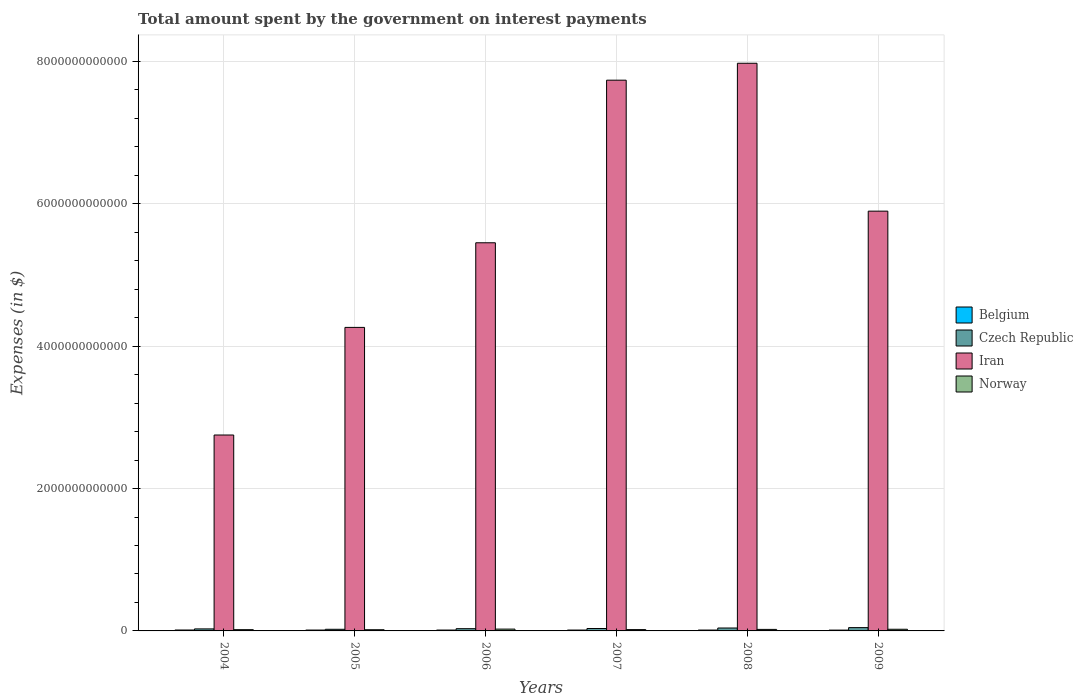How many different coloured bars are there?
Your response must be concise. 4. How many bars are there on the 3rd tick from the left?
Provide a succinct answer. 4. In how many cases, is the number of bars for a given year not equal to the number of legend labels?
Your response must be concise. 0. What is the amount spent on interest payments by the government in Belgium in 2008?
Give a very brief answer. 1.23e+1. Across all years, what is the maximum amount spent on interest payments by the government in Norway?
Keep it short and to the point. 2.56e+1. Across all years, what is the minimum amount spent on interest payments by the government in Belgium?
Your answer should be compact. 1.16e+1. What is the total amount spent on interest payments by the government in Iran in the graph?
Ensure brevity in your answer.  3.41e+13. What is the difference between the amount spent on interest payments by the government in Belgium in 2004 and that in 2008?
Your response must be concise. 5.26e+08. What is the difference between the amount spent on interest payments by the government in Iran in 2007 and the amount spent on interest payments by the government in Belgium in 2005?
Provide a short and direct response. 7.72e+12. What is the average amount spent on interest payments by the government in Belgium per year?
Offer a very short reply. 1.22e+1. In the year 2009, what is the difference between the amount spent on interest payments by the government in Norway and amount spent on interest payments by the government in Czech Republic?
Offer a very short reply. -2.29e+1. In how many years, is the amount spent on interest payments by the government in Iran greater than 5200000000000 $?
Your answer should be very brief. 4. What is the ratio of the amount spent on interest payments by the government in Czech Republic in 2004 to that in 2007?
Keep it short and to the point. 0.83. What is the difference between the highest and the second highest amount spent on interest payments by the government in Norway?
Your answer should be very brief. 2.15e+09. What is the difference between the highest and the lowest amount spent on interest payments by the government in Iran?
Your answer should be compact. 5.22e+12. In how many years, is the amount spent on interest payments by the government in Belgium greater than the average amount spent on interest payments by the government in Belgium taken over all years?
Make the answer very short. 3. Is the sum of the amount spent on interest payments by the government in Iran in 2007 and 2008 greater than the maximum amount spent on interest payments by the government in Czech Republic across all years?
Offer a very short reply. Yes. Is it the case that in every year, the sum of the amount spent on interest payments by the government in Iran and amount spent on interest payments by the government in Czech Republic is greater than the sum of amount spent on interest payments by the government in Belgium and amount spent on interest payments by the government in Norway?
Ensure brevity in your answer.  Yes. What does the 3rd bar from the left in 2008 represents?
Your answer should be compact. Iran. What does the 3rd bar from the right in 2008 represents?
Provide a succinct answer. Czech Republic. Is it the case that in every year, the sum of the amount spent on interest payments by the government in Czech Republic and amount spent on interest payments by the government in Belgium is greater than the amount spent on interest payments by the government in Norway?
Ensure brevity in your answer.  Yes. Are all the bars in the graph horizontal?
Give a very brief answer. No. What is the difference between two consecutive major ticks on the Y-axis?
Ensure brevity in your answer.  2.00e+12. Are the values on the major ticks of Y-axis written in scientific E-notation?
Ensure brevity in your answer.  No. Does the graph contain any zero values?
Your response must be concise. No. Does the graph contain grids?
Provide a short and direct response. Yes. Where does the legend appear in the graph?
Offer a terse response. Center right. How many legend labels are there?
Provide a succinct answer. 4. What is the title of the graph?
Ensure brevity in your answer.  Total amount spent by the government on interest payments. What is the label or title of the X-axis?
Offer a very short reply. Years. What is the label or title of the Y-axis?
Offer a terse response. Expenses (in $). What is the Expenses (in $) of Belgium in 2004?
Offer a terse response. 1.28e+1. What is the Expenses (in $) of Czech Republic in 2004?
Offer a terse response. 2.83e+1. What is the Expenses (in $) of Iran in 2004?
Your response must be concise. 2.75e+12. What is the Expenses (in $) in Norway in 2004?
Provide a short and direct response. 1.77e+1. What is the Expenses (in $) in Belgium in 2005?
Your answer should be compact. 1.22e+1. What is the Expenses (in $) of Czech Republic in 2005?
Ensure brevity in your answer.  2.30e+1. What is the Expenses (in $) of Iran in 2005?
Offer a terse response. 4.26e+12. What is the Expenses (in $) of Norway in 2005?
Your response must be concise. 1.67e+1. What is the Expenses (in $) in Belgium in 2006?
Your answer should be compact. 1.21e+1. What is the Expenses (in $) in Czech Republic in 2006?
Give a very brief answer. 3.14e+1. What is the Expenses (in $) of Iran in 2006?
Offer a terse response. 5.45e+12. What is the Expenses (in $) in Norway in 2006?
Provide a succinct answer. 2.56e+1. What is the Expenses (in $) in Belgium in 2007?
Offer a very short reply. 1.21e+1. What is the Expenses (in $) in Czech Republic in 2007?
Ensure brevity in your answer.  3.40e+1. What is the Expenses (in $) in Iran in 2007?
Give a very brief answer. 7.74e+12. What is the Expenses (in $) in Norway in 2007?
Provide a succinct answer. 1.86e+1. What is the Expenses (in $) in Belgium in 2008?
Make the answer very short. 1.23e+1. What is the Expenses (in $) of Czech Republic in 2008?
Keep it short and to the point. 4.09e+1. What is the Expenses (in $) in Iran in 2008?
Keep it short and to the point. 7.97e+12. What is the Expenses (in $) of Norway in 2008?
Your answer should be very brief. 2.13e+1. What is the Expenses (in $) of Belgium in 2009?
Ensure brevity in your answer.  1.16e+1. What is the Expenses (in $) in Czech Republic in 2009?
Keep it short and to the point. 4.64e+1. What is the Expenses (in $) of Iran in 2009?
Your answer should be very brief. 5.90e+12. What is the Expenses (in $) in Norway in 2009?
Provide a short and direct response. 2.34e+1. Across all years, what is the maximum Expenses (in $) in Belgium?
Offer a very short reply. 1.28e+1. Across all years, what is the maximum Expenses (in $) of Czech Republic?
Offer a terse response. 4.64e+1. Across all years, what is the maximum Expenses (in $) in Iran?
Ensure brevity in your answer.  7.97e+12. Across all years, what is the maximum Expenses (in $) in Norway?
Make the answer very short. 2.56e+1. Across all years, what is the minimum Expenses (in $) of Belgium?
Offer a very short reply. 1.16e+1. Across all years, what is the minimum Expenses (in $) of Czech Republic?
Provide a short and direct response. 2.30e+1. Across all years, what is the minimum Expenses (in $) in Iran?
Provide a succinct answer. 2.75e+12. Across all years, what is the minimum Expenses (in $) in Norway?
Your answer should be compact. 1.67e+1. What is the total Expenses (in $) of Belgium in the graph?
Your response must be concise. 7.30e+1. What is the total Expenses (in $) in Czech Republic in the graph?
Make the answer very short. 2.04e+11. What is the total Expenses (in $) of Iran in the graph?
Keep it short and to the point. 3.41e+13. What is the total Expenses (in $) of Norway in the graph?
Provide a succinct answer. 1.23e+11. What is the difference between the Expenses (in $) in Belgium in 2004 and that in 2005?
Provide a short and direct response. 6.13e+08. What is the difference between the Expenses (in $) of Czech Republic in 2004 and that in 2005?
Keep it short and to the point. 5.31e+09. What is the difference between the Expenses (in $) in Iran in 2004 and that in 2005?
Your response must be concise. -1.51e+12. What is the difference between the Expenses (in $) in Norway in 2004 and that in 2005?
Make the answer very short. 9.82e+08. What is the difference between the Expenses (in $) of Belgium in 2004 and that in 2006?
Ensure brevity in your answer.  7.07e+08. What is the difference between the Expenses (in $) of Czech Republic in 2004 and that in 2006?
Your response must be concise. -3.06e+09. What is the difference between the Expenses (in $) in Iran in 2004 and that in 2006?
Your answer should be compact. -2.70e+12. What is the difference between the Expenses (in $) in Norway in 2004 and that in 2006?
Ensure brevity in your answer.  -7.91e+09. What is the difference between the Expenses (in $) of Belgium in 2004 and that in 2007?
Ensure brevity in your answer.  6.55e+08. What is the difference between the Expenses (in $) of Czech Republic in 2004 and that in 2007?
Offer a very short reply. -5.62e+09. What is the difference between the Expenses (in $) in Iran in 2004 and that in 2007?
Provide a short and direct response. -4.98e+12. What is the difference between the Expenses (in $) in Norway in 2004 and that in 2007?
Your answer should be compact. -8.98e+08. What is the difference between the Expenses (in $) in Belgium in 2004 and that in 2008?
Your answer should be compact. 5.26e+08. What is the difference between the Expenses (in $) of Czech Republic in 2004 and that in 2008?
Make the answer very short. -1.26e+1. What is the difference between the Expenses (in $) of Iran in 2004 and that in 2008?
Offer a terse response. -5.22e+12. What is the difference between the Expenses (in $) of Norway in 2004 and that in 2008?
Your answer should be compact. -3.65e+09. What is the difference between the Expenses (in $) of Belgium in 2004 and that in 2009?
Give a very brief answer. 1.23e+09. What is the difference between the Expenses (in $) of Czech Republic in 2004 and that in 2009?
Offer a terse response. -1.80e+1. What is the difference between the Expenses (in $) in Iran in 2004 and that in 2009?
Keep it short and to the point. -3.14e+12. What is the difference between the Expenses (in $) of Norway in 2004 and that in 2009?
Provide a succinct answer. -5.76e+09. What is the difference between the Expenses (in $) in Belgium in 2005 and that in 2006?
Provide a succinct answer. 9.46e+07. What is the difference between the Expenses (in $) of Czech Republic in 2005 and that in 2006?
Provide a short and direct response. -8.37e+09. What is the difference between the Expenses (in $) in Iran in 2005 and that in 2006?
Give a very brief answer. -1.19e+12. What is the difference between the Expenses (in $) in Norway in 2005 and that in 2006?
Give a very brief answer. -8.89e+09. What is the difference between the Expenses (in $) in Belgium in 2005 and that in 2007?
Offer a terse response. 4.20e+07. What is the difference between the Expenses (in $) of Czech Republic in 2005 and that in 2007?
Your answer should be very brief. -1.09e+1. What is the difference between the Expenses (in $) of Iran in 2005 and that in 2007?
Provide a short and direct response. -3.47e+12. What is the difference between the Expenses (in $) of Norway in 2005 and that in 2007?
Make the answer very short. -1.88e+09. What is the difference between the Expenses (in $) in Belgium in 2005 and that in 2008?
Make the answer very short. -8.66e+07. What is the difference between the Expenses (in $) of Czech Republic in 2005 and that in 2008?
Your answer should be very brief. -1.79e+1. What is the difference between the Expenses (in $) of Iran in 2005 and that in 2008?
Give a very brief answer. -3.71e+12. What is the difference between the Expenses (in $) in Norway in 2005 and that in 2008?
Your answer should be compact. -4.63e+09. What is the difference between the Expenses (in $) of Belgium in 2005 and that in 2009?
Offer a terse response. 6.20e+08. What is the difference between the Expenses (in $) in Czech Republic in 2005 and that in 2009?
Your response must be concise. -2.33e+1. What is the difference between the Expenses (in $) in Iran in 2005 and that in 2009?
Your response must be concise. -1.63e+12. What is the difference between the Expenses (in $) of Norway in 2005 and that in 2009?
Provide a short and direct response. -6.74e+09. What is the difference between the Expenses (in $) of Belgium in 2006 and that in 2007?
Offer a terse response. -5.26e+07. What is the difference between the Expenses (in $) of Czech Republic in 2006 and that in 2007?
Keep it short and to the point. -2.56e+09. What is the difference between the Expenses (in $) in Iran in 2006 and that in 2007?
Ensure brevity in your answer.  -2.28e+12. What is the difference between the Expenses (in $) of Norway in 2006 and that in 2007?
Give a very brief answer. 7.01e+09. What is the difference between the Expenses (in $) in Belgium in 2006 and that in 2008?
Provide a succinct answer. -1.81e+08. What is the difference between the Expenses (in $) of Czech Republic in 2006 and that in 2008?
Offer a terse response. -9.55e+09. What is the difference between the Expenses (in $) in Iran in 2006 and that in 2008?
Provide a succinct answer. -2.52e+12. What is the difference between the Expenses (in $) in Norway in 2006 and that in 2008?
Ensure brevity in your answer.  4.26e+09. What is the difference between the Expenses (in $) in Belgium in 2006 and that in 2009?
Offer a terse response. 5.25e+08. What is the difference between the Expenses (in $) of Czech Republic in 2006 and that in 2009?
Provide a short and direct response. -1.50e+1. What is the difference between the Expenses (in $) of Iran in 2006 and that in 2009?
Your response must be concise. -4.44e+11. What is the difference between the Expenses (in $) in Norway in 2006 and that in 2009?
Your answer should be compact. 2.15e+09. What is the difference between the Expenses (in $) of Belgium in 2007 and that in 2008?
Provide a short and direct response. -1.29e+08. What is the difference between the Expenses (in $) of Czech Republic in 2007 and that in 2008?
Ensure brevity in your answer.  -6.98e+09. What is the difference between the Expenses (in $) in Iran in 2007 and that in 2008?
Keep it short and to the point. -2.38e+11. What is the difference between the Expenses (in $) in Norway in 2007 and that in 2008?
Your answer should be very brief. -2.75e+09. What is the difference between the Expenses (in $) of Belgium in 2007 and that in 2009?
Provide a short and direct response. 5.78e+08. What is the difference between the Expenses (in $) in Czech Republic in 2007 and that in 2009?
Give a very brief answer. -1.24e+1. What is the difference between the Expenses (in $) of Iran in 2007 and that in 2009?
Provide a short and direct response. 1.84e+12. What is the difference between the Expenses (in $) in Norway in 2007 and that in 2009?
Give a very brief answer. -4.86e+09. What is the difference between the Expenses (in $) in Belgium in 2008 and that in 2009?
Provide a short and direct response. 7.06e+08. What is the difference between the Expenses (in $) in Czech Republic in 2008 and that in 2009?
Offer a very short reply. -5.42e+09. What is the difference between the Expenses (in $) of Iran in 2008 and that in 2009?
Provide a short and direct response. 2.08e+12. What is the difference between the Expenses (in $) of Norway in 2008 and that in 2009?
Provide a short and direct response. -2.11e+09. What is the difference between the Expenses (in $) in Belgium in 2004 and the Expenses (in $) in Czech Republic in 2005?
Give a very brief answer. -1.02e+1. What is the difference between the Expenses (in $) of Belgium in 2004 and the Expenses (in $) of Iran in 2005?
Make the answer very short. -4.25e+12. What is the difference between the Expenses (in $) of Belgium in 2004 and the Expenses (in $) of Norway in 2005?
Provide a short and direct response. -3.91e+09. What is the difference between the Expenses (in $) in Czech Republic in 2004 and the Expenses (in $) in Iran in 2005?
Offer a very short reply. -4.24e+12. What is the difference between the Expenses (in $) of Czech Republic in 2004 and the Expenses (in $) of Norway in 2005?
Give a very brief answer. 1.16e+1. What is the difference between the Expenses (in $) in Iran in 2004 and the Expenses (in $) in Norway in 2005?
Keep it short and to the point. 2.74e+12. What is the difference between the Expenses (in $) of Belgium in 2004 and the Expenses (in $) of Czech Republic in 2006?
Offer a very short reply. -1.86e+1. What is the difference between the Expenses (in $) in Belgium in 2004 and the Expenses (in $) in Iran in 2006?
Make the answer very short. -5.44e+12. What is the difference between the Expenses (in $) of Belgium in 2004 and the Expenses (in $) of Norway in 2006?
Your answer should be very brief. -1.28e+1. What is the difference between the Expenses (in $) of Czech Republic in 2004 and the Expenses (in $) of Iran in 2006?
Make the answer very short. -5.42e+12. What is the difference between the Expenses (in $) in Czech Republic in 2004 and the Expenses (in $) in Norway in 2006?
Ensure brevity in your answer.  2.75e+09. What is the difference between the Expenses (in $) in Iran in 2004 and the Expenses (in $) in Norway in 2006?
Offer a very short reply. 2.73e+12. What is the difference between the Expenses (in $) in Belgium in 2004 and the Expenses (in $) in Czech Republic in 2007?
Provide a short and direct response. -2.12e+1. What is the difference between the Expenses (in $) in Belgium in 2004 and the Expenses (in $) in Iran in 2007?
Keep it short and to the point. -7.72e+12. What is the difference between the Expenses (in $) of Belgium in 2004 and the Expenses (in $) of Norway in 2007?
Your answer should be compact. -5.79e+09. What is the difference between the Expenses (in $) of Czech Republic in 2004 and the Expenses (in $) of Iran in 2007?
Your answer should be compact. -7.71e+12. What is the difference between the Expenses (in $) of Czech Republic in 2004 and the Expenses (in $) of Norway in 2007?
Ensure brevity in your answer.  9.76e+09. What is the difference between the Expenses (in $) in Iran in 2004 and the Expenses (in $) in Norway in 2007?
Your response must be concise. 2.73e+12. What is the difference between the Expenses (in $) of Belgium in 2004 and the Expenses (in $) of Czech Republic in 2008?
Keep it short and to the point. -2.82e+1. What is the difference between the Expenses (in $) of Belgium in 2004 and the Expenses (in $) of Iran in 2008?
Ensure brevity in your answer.  -7.96e+12. What is the difference between the Expenses (in $) in Belgium in 2004 and the Expenses (in $) in Norway in 2008?
Offer a very short reply. -8.54e+09. What is the difference between the Expenses (in $) of Czech Republic in 2004 and the Expenses (in $) of Iran in 2008?
Make the answer very short. -7.95e+12. What is the difference between the Expenses (in $) in Czech Republic in 2004 and the Expenses (in $) in Norway in 2008?
Offer a very short reply. 7.01e+09. What is the difference between the Expenses (in $) in Iran in 2004 and the Expenses (in $) in Norway in 2008?
Ensure brevity in your answer.  2.73e+12. What is the difference between the Expenses (in $) in Belgium in 2004 and the Expenses (in $) in Czech Republic in 2009?
Keep it short and to the point. -3.36e+1. What is the difference between the Expenses (in $) in Belgium in 2004 and the Expenses (in $) in Iran in 2009?
Ensure brevity in your answer.  -5.88e+12. What is the difference between the Expenses (in $) of Belgium in 2004 and the Expenses (in $) of Norway in 2009?
Ensure brevity in your answer.  -1.07e+1. What is the difference between the Expenses (in $) in Czech Republic in 2004 and the Expenses (in $) in Iran in 2009?
Make the answer very short. -5.87e+12. What is the difference between the Expenses (in $) in Czech Republic in 2004 and the Expenses (in $) in Norway in 2009?
Ensure brevity in your answer.  4.90e+09. What is the difference between the Expenses (in $) of Iran in 2004 and the Expenses (in $) of Norway in 2009?
Keep it short and to the point. 2.73e+12. What is the difference between the Expenses (in $) of Belgium in 2005 and the Expenses (in $) of Czech Republic in 2006?
Offer a very short reply. -1.92e+1. What is the difference between the Expenses (in $) in Belgium in 2005 and the Expenses (in $) in Iran in 2006?
Offer a very short reply. -5.44e+12. What is the difference between the Expenses (in $) of Belgium in 2005 and the Expenses (in $) of Norway in 2006?
Provide a short and direct response. -1.34e+1. What is the difference between the Expenses (in $) of Czech Republic in 2005 and the Expenses (in $) of Iran in 2006?
Ensure brevity in your answer.  -5.43e+12. What is the difference between the Expenses (in $) in Czech Republic in 2005 and the Expenses (in $) in Norway in 2006?
Offer a very short reply. -2.56e+09. What is the difference between the Expenses (in $) of Iran in 2005 and the Expenses (in $) of Norway in 2006?
Offer a very short reply. 4.24e+12. What is the difference between the Expenses (in $) in Belgium in 2005 and the Expenses (in $) in Czech Republic in 2007?
Your answer should be very brief. -2.18e+1. What is the difference between the Expenses (in $) in Belgium in 2005 and the Expenses (in $) in Iran in 2007?
Provide a succinct answer. -7.72e+12. What is the difference between the Expenses (in $) in Belgium in 2005 and the Expenses (in $) in Norway in 2007?
Provide a short and direct response. -6.41e+09. What is the difference between the Expenses (in $) of Czech Republic in 2005 and the Expenses (in $) of Iran in 2007?
Provide a succinct answer. -7.71e+12. What is the difference between the Expenses (in $) in Czech Republic in 2005 and the Expenses (in $) in Norway in 2007?
Keep it short and to the point. 4.45e+09. What is the difference between the Expenses (in $) in Iran in 2005 and the Expenses (in $) in Norway in 2007?
Offer a terse response. 4.25e+12. What is the difference between the Expenses (in $) in Belgium in 2005 and the Expenses (in $) in Czech Republic in 2008?
Make the answer very short. -2.88e+1. What is the difference between the Expenses (in $) in Belgium in 2005 and the Expenses (in $) in Iran in 2008?
Provide a short and direct response. -7.96e+12. What is the difference between the Expenses (in $) of Belgium in 2005 and the Expenses (in $) of Norway in 2008?
Offer a very short reply. -9.16e+09. What is the difference between the Expenses (in $) in Czech Republic in 2005 and the Expenses (in $) in Iran in 2008?
Provide a succinct answer. -7.95e+12. What is the difference between the Expenses (in $) of Czech Republic in 2005 and the Expenses (in $) of Norway in 2008?
Offer a terse response. 1.70e+09. What is the difference between the Expenses (in $) in Iran in 2005 and the Expenses (in $) in Norway in 2008?
Your response must be concise. 4.24e+12. What is the difference between the Expenses (in $) in Belgium in 2005 and the Expenses (in $) in Czech Republic in 2009?
Offer a very short reply. -3.42e+1. What is the difference between the Expenses (in $) in Belgium in 2005 and the Expenses (in $) in Iran in 2009?
Keep it short and to the point. -5.88e+12. What is the difference between the Expenses (in $) in Belgium in 2005 and the Expenses (in $) in Norway in 2009?
Give a very brief answer. -1.13e+1. What is the difference between the Expenses (in $) of Czech Republic in 2005 and the Expenses (in $) of Iran in 2009?
Give a very brief answer. -5.87e+12. What is the difference between the Expenses (in $) in Czech Republic in 2005 and the Expenses (in $) in Norway in 2009?
Offer a terse response. -4.14e+08. What is the difference between the Expenses (in $) in Iran in 2005 and the Expenses (in $) in Norway in 2009?
Keep it short and to the point. 4.24e+12. What is the difference between the Expenses (in $) in Belgium in 2006 and the Expenses (in $) in Czech Republic in 2007?
Your response must be concise. -2.19e+1. What is the difference between the Expenses (in $) in Belgium in 2006 and the Expenses (in $) in Iran in 2007?
Offer a terse response. -7.72e+12. What is the difference between the Expenses (in $) of Belgium in 2006 and the Expenses (in $) of Norway in 2007?
Your answer should be compact. -6.50e+09. What is the difference between the Expenses (in $) in Czech Republic in 2006 and the Expenses (in $) in Iran in 2007?
Ensure brevity in your answer.  -7.71e+12. What is the difference between the Expenses (in $) of Czech Republic in 2006 and the Expenses (in $) of Norway in 2007?
Ensure brevity in your answer.  1.28e+1. What is the difference between the Expenses (in $) in Iran in 2006 and the Expenses (in $) in Norway in 2007?
Keep it short and to the point. 5.43e+12. What is the difference between the Expenses (in $) in Belgium in 2006 and the Expenses (in $) in Czech Republic in 2008?
Your answer should be very brief. -2.89e+1. What is the difference between the Expenses (in $) of Belgium in 2006 and the Expenses (in $) of Iran in 2008?
Your answer should be very brief. -7.96e+12. What is the difference between the Expenses (in $) in Belgium in 2006 and the Expenses (in $) in Norway in 2008?
Provide a short and direct response. -9.25e+09. What is the difference between the Expenses (in $) of Czech Republic in 2006 and the Expenses (in $) of Iran in 2008?
Ensure brevity in your answer.  -7.94e+12. What is the difference between the Expenses (in $) in Czech Republic in 2006 and the Expenses (in $) in Norway in 2008?
Ensure brevity in your answer.  1.01e+1. What is the difference between the Expenses (in $) in Iran in 2006 and the Expenses (in $) in Norway in 2008?
Ensure brevity in your answer.  5.43e+12. What is the difference between the Expenses (in $) of Belgium in 2006 and the Expenses (in $) of Czech Republic in 2009?
Offer a very short reply. -3.43e+1. What is the difference between the Expenses (in $) of Belgium in 2006 and the Expenses (in $) of Iran in 2009?
Keep it short and to the point. -5.88e+12. What is the difference between the Expenses (in $) of Belgium in 2006 and the Expenses (in $) of Norway in 2009?
Give a very brief answer. -1.14e+1. What is the difference between the Expenses (in $) in Czech Republic in 2006 and the Expenses (in $) in Iran in 2009?
Your response must be concise. -5.87e+12. What is the difference between the Expenses (in $) of Czech Republic in 2006 and the Expenses (in $) of Norway in 2009?
Offer a very short reply. 7.96e+09. What is the difference between the Expenses (in $) in Iran in 2006 and the Expenses (in $) in Norway in 2009?
Offer a terse response. 5.43e+12. What is the difference between the Expenses (in $) in Belgium in 2007 and the Expenses (in $) in Czech Republic in 2008?
Your answer should be very brief. -2.88e+1. What is the difference between the Expenses (in $) in Belgium in 2007 and the Expenses (in $) in Iran in 2008?
Keep it short and to the point. -7.96e+12. What is the difference between the Expenses (in $) of Belgium in 2007 and the Expenses (in $) of Norway in 2008?
Provide a succinct answer. -9.20e+09. What is the difference between the Expenses (in $) of Czech Republic in 2007 and the Expenses (in $) of Iran in 2008?
Keep it short and to the point. -7.94e+12. What is the difference between the Expenses (in $) in Czech Republic in 2007 and the Expenses (in $) in Norway in 2008?
Offer a very short reply. 1.26e+1. What is the difference between the Expenses (in $) in Iran in 2007 and the Expenses (in $) in Norway in 2008?
Give a very brief answer. 7.72e+12. What is the difference between the Expenses (in $) in Belgium in 2007 and the Expenses (in $) in Czech Republic in 2009?
Your answer should be compact. -3.42e+1. What is the difference between the Expenses (in $) of Belgium in 2007 and the Expenses (in $) of Iran in 2009?
Offer a very short reply. -5.88e+12. What is the difference between the Expenses (in $) in Belgium in 2007 and the Expenses (in $) in Norway in 2009?
Make the answer very short. -1.13e+1. What is the difference between the Expenses (in $) in Czech Republic in 2007 and the Expenses (in $) in Iran in 2009?
Offer a terse response. -5.86e+12. What is the difference between the Expenses (in $) in Czech Republic in 2007 and the Expenses (in $) in Norway in 2009?
Keep it short and to the point. 1.05e+1. What is the difference between the Expenses (in $) of Iran in 2007 and the Expenses (in $) of Norway in 2009?
Keep it short and to the point. 7.71e+12. What is the difference between the Expenses (in $) of Belgium in 2008 and the Expenses (in $) of Czech Republic in 2009?
Provide a succinct answer. -3.41e+1. What is the difference between the Expenses (in $) in Belgium in 2008 and the Expenses (in $) in Iran in 2009?
Make the answer very short. -5.88e+12. What is the difference between the Expenses (in $) of Belgium in 2008 and the Expenses (in $) of Norway in 2009?
Offer a terse response. -1.12e+1. What is the difference between the Expenses (in $) in Czech Republic in 2008 and the Expenses (in $) in Iran in 2009?
Provide a short and direct response. -5.86e+12. What is the difference between the Expenses (in $) of Czech Republic in 2008 and the Expenses (in $) of Norway in 2009?
Keep it short and to the point. 1.75e+1. What is the difference between the Expenses (in $) in Iran in 2008 and the Expenses (in $) in Norway in 2009?
Your answer should be very brief. 7.95e+12. What is the average Expenses (in $) in Belgium per year?
Provide a succinct answer. 1.22e+1. What is the average Expenses (in $) in Czech Republic per year?
Offer a very short reply. 3.40e+1. What is the average Expenses (in $) in Iran per year?
Ensure brevity in your answer.  5.68e+12. What is the average Expenses (in $) of Norway per year?
Your response must be concise. 2.06e+1. In the year 2004, what is the difference between the Expenses (in $) of Belgium and Expenses (in $) of Czech Republic?
Your answer should be compact. -1.56e+1. In the year 2004, what is the difference between the Expenses (in $) in Belgium and Expenses (in $) in Iran?
Provide a short and direct response. -2.74e+12. In the year 2004, what is the difference between the Expenses (in $) in Belgium and Expenses (in $) in Norway?
Your response must be concise. -4.90e+09. In the year 2004, what is the difference between the Expenses (in $) in Czech Republic and Expenses (in $) in Iran?
Provide a short and direct response. -2.72e+12. In the year 2004, what is the difference between the Expenses (in $) of Czech Republic and Expenses (in $) of Norway?
Give a very brief answer. 1.07e+1. In the year 2004, what is the difference between the Expenses (in $) of Iran and Expenses (in $) of Norway?
Provide a succinct answer. 2.73e+12. In the year 2005, what is the difference between the Expenses (in $) of Belgium and Expenses (in $) of Czech Republic?
Offer a very short reply. -1.09e+1. In the year 2005, what is the difference between the Expenses (in $) of Belgium and Expenses (in $) of Iran?
Ensure brevity in your answer.  -4.25e+12. In the year 2005, what is the difference between the Expenses (in $) of Belgium and Expenses (in $) of Norway?
Give a very brief answer. -4.53e+09. In the year 2005, what is the difference between the Expenses (in $) of Czech Republic and Expenses (in $) of Iran?
Provide a short and direct response. -4.24e+12. In the year 2005, what is the difference between the Expenses (in $) in Czech Republic and Expenses (in $) in Norway?
Your answer should be very brief. 6.33e+09. In the year 2005, what is the difference between the Expenses (in $) in Iran and Expenses (in $) in Norway?
Make the answer very short. 4.25e+12. In the year 2006, what is the difference between the Expenses (in $) in Belgium and Expenses (in $) in Czech Republic?
Offer a very short reply. -1.93e+1. In the year 2006, what is the difference between the Expenses (in $) of Belgium and Expenses (in $) of Iran?
Provide a succinct answer. -5.44e+12. In the year 2006, what is the difference between the Expenses (in $) of Belgium and Expenses (in $) of Norway?
Provide a succinct answer. -1.35e+1. In the year 2006, what is the difference between the Expenses (in $) of Czech Republic and Expenses (in $) of Iran?
Offer a very short reply. -5.42e+12. In the year 2006, what is the difference between the Expenses (in $) of Czech Republic and Expenses (in $) of Norway?
Your response must be concise. 5.81e+09. In the year 2006, what is the difference between the Expenses (in $) in Iran and Expenses (in $) in Norway?
Give a very brief answer. 5.43e+12. In the year 2007, what is the difference between the Expenses (in $) in Belgium and Expenses (in $) in Czech Republic?
Give a very brief answer. -2.18e+1. In the year 2007, what is the difference between the Expenses (in $) of Belgium and Expenses (in $) of Iran?
Provide a short and direct response. -7.72e+12. In the year 2007, what is the difference between the Expenses (in $) of Belgium and Expenses (in $) of Norway?
Provide a short and direct response. -6.45e+09. In the year 2007, what is the difference between the Expenses (in $) in Czech Republic and Expenses (in $) in Iran?
Ensure brevity in your answer.  -7.70e+12. In the year 2007, what is the difference between the Expenses (in $) in Czech Republic and Expenses (in $) in Norway?
Give a very brief answer. 1.54e+1. In the year 2007, what is the difference between the Expenses (in $) in Iran and Expenses (in $) in Norway?
Your response must be concise. 7.72e+12. In the year 2008, what is the difference between the Expenses (in $) in Belgium and Expenses (in $) in Czech Republic?
Give a very brief answer. -2.87e+1. In the year 2008, what is the difference between the Expenses (in $) of Belgium and Expenses (in $) of Iran?
Offer a very short reply. -7.96e+12. In the year 2008, what is the difference between the Expenses (in $) in Belgium and Expenses (in $) in Norway?
Provide a succinct answer. -9.07e+09. In the year 2008, what is the difference between the Expenses (in $) in Czech Republic and Expenses (in $) in Iran?
Keep it short and to the point. -7.93e+12. In the year 2008, what is the difference between the Expenses (in $) of Czech Republic and Expenses (in $) of Norway?
Your answer should be very brief. 1.96e+1. In the year 2008, what is the difference between the Expenses (in $) of Iran and Expenses (in $) of Norway?
Make the answer very short. 7.95e+12. In the year 2009, what is the difference between the Expenses (in $) in Belgium and Expenses (in $) in Czech Republic?
Ensure brevity in your answer.  -3.48e+1. In the year 2009, what is the difference between the Expenses (in $) of Belgium and Expenses (in $) of Iran?
Ensure brevity in your answer.  -5.89e+12. In the year 2009, what is the difference between the Expenses (in $) in Belgium and Expenses (in $) in Norway?
Provide a succinct answer. -1.19e+1. In the year 2009, what is the difference between the Expenses (in $) of Czech Republic and Expenses (in $) of Iran?
Your response must be concise. -5.85e+12. In the year 2009, what is the difference between the Expenses (in $) in Czech Republic and Expenses (in $) in Norway?
Offer a very short reply. 2.29e+1. In the year 2009, what is the difference between the Expenses (in $) in Iran and Expenses (in $) in Norway?
Your answer should be compact. 5.87e+12. What is the ratio of the Expenses (in $) in Belgium in 2004 to that in 2005?
Provide a succinct answer. 1.05. What is the ratio of the Expenses (in $) of Czech Republic in 2004 to that in 2005?
Offer a very short reply. 1.23. What is the ratio of the Expenses (in $) in Iran in 2004 to that in 2005?
Your answer should be very brief. 0.65. What is the ratio of the Expenses (in $) of Norway in 2004 to that in 2005?
Offer a very short reply. 1.06. What is the ratio of the Expenses (in $) in Belgium in 2004 to that in 2006?
Your answer should be compact. 1.06. What is the ratio of the Expenses (in $) of Czech Republic in 2004 to that in 2006?
Keep it short and to the point. 0.9. What is the ratio of the Expenses (in $) in Iran in 2004 to that in 2006?
Give a very brief answer. 0.5. What is the ratio of the Expenses (in $) in Norway in 2004 to that in 2006?
Provide a succinct answer. 0.69. What is the ratio of the Expenses (in $) of Belgium in 2004 to that in 2007?
Provide a succinct answer. 1.05. What is the ratio of the Expenses (in $) of Czech Republic in 2004 to that in 2007?
Your response must be concise. 0.83. What is the ratio of the Expenses (in $) in Iran in 2004 to that in 2007?
Provide a short and direct response. 0.36. What is the ratio of the Expenses (in $) in Norway in 2004 to that in 2007?
Your answer should be very brief. 0.95. What is the ratio of the Expenses (in $) in Belgium in 2004 to that in 2008?
Make the answer very short. 1.04. What is the ratio of the Expenses (in $) in Czech Republic in 2004 to that in 2008?
Offer a very short reply. 0.69. What is the ratio of the Expenses (in $) of Iran in 2004 to that in 2008?
Keep it short and to the point. 0.35. What is the ratio of the Expenses (in $) in Norway in 2004 to that in 2008?
Keep it short and to the point. 0.83. What is the ratio of the Expenses (in $) of Belgium in 2004 to that in 2009?
Offer a very short reply. 1.11. What is the ratio of the Expenses (in $) in Czech Republic in 2004 to that in 2009?
Provide a short and direct response. 0.61. What is the ratio of the Expenses (in $) of Iran in 2004 to that in 2009?
Your answer should be compact. 0.47. What is the ratio of the Expenses (in $) in Norway in 2004 to that in 2009?
Ensure brevity in your answer.  0.75. What is the ratio of the Expenses (in $) of Belgium in 2005 to that in 2006?
Make the answer very short. 1.01. What is the ratio of the Expenses (in $) of Czech Republic in 2005 to that in 2006?
Offer a terse response. 0.73. What is the ratio of the Expenses (in $) of Iran in 2005 to that in 2006?
Offer a terse response. 0.78. What is the ratio of the Expenses (in $) of Norway in 2005 to that in 2006?
Provide a succinct answer. 0.65. What is the ratio of the Expenses (in $) of Belgium in 2005 to that in 2007?
Keep it short and to the point. 1. What is the ratio of the Expenses (in $) in Czech Republic in 2005 to that in 2007?
Your answer should be compact. 0.68. What is the ratio of the Expenses (in $) of Iran in 2005 to that in 2007?
Give a very brief answer. 0.55. What is the ratio of the Expenses (in $) of Norway in 2005 to that in 2007?
Your answer should be compact. 0.9. What is the ratio of the Expenses (in $) in Belgium in 2005 to that in 2008?
Ensure brevity in your answer.  0.99. What is the ratio of the Expenses (in $) in Czech Republic in 2005 to that in 2008?
Offer a very short reply. 0.56. What is the ratio of the Expenses (in $) of Iran in 2005 to that in 2008?
Give a very brief answer. 0.53. What is the ratio of the Expenses (in $) in Norway in 2005 to that in 2008?
Your answer should be very brief. 0.78. What is the ratio of the Expenses (in $) of Belgium in 2005 to that in 2009?
Your answer should be very brief. 1.05. What is the ratio of the Expenses (in $) in Czech Republic in 2005 to that in 2009?
Provide a short and direct response. 0.5. What is the ratio of the Expenses (in $) in Iran in 2005 to that in 2009?
Offer a very short reply. 0.72. What is the ratio of the Expenses (in $) of Norway in 2005 to that in 2009?
Offer a terse response. 0.71. What is the ratio of the Expenses (in $) of Czech Republic in 2006 to that in 2007?
Your answer should be compact. 0.92. What is the ratio of the Expenses (in $) in Iran in 2006 to that in 2007?
Provide a short and direct response. 0.7. What is the ratio of the Expenses (in $) of Norway in 2006 to that in 2007?
Offer a very short reply. 1.38. What is the ratio of the Expenses (in $) of Belgium in 2006 to that in 2008?
Ensure brevity in your answer.  0.99. What is the ratio of the Expenses (in $) of Czech Republic in 2006 to that in 2008?
Your answer should be very brief. 0.77. What is the ratio of the Expenses (in $) in Iran in 2006 to that in 2008?
Offer a very short reply. 0.68. What is the ratio of the Expenses (in $) of Norway in 2006 to that in 2008?
Keep it short and to the point. 1.2. What is the ratio of the Expenses (in $) in Belgium in 2006 to that in 2009?
Your answer should be very brief. 1.05. What is the ratio of the Expenses (in $) of Czech Republic in 2006 to that in 2009?
Give a very brief answer. 0.68. What is the ratio of the Expenses (in $) of Iran in 2006 to that in 2009?
Give a very brief answer. 0.92. What is the ratio of the Expenses (in $) in Norway in 2006 to that in 2009?
Make the answer very short. 1.09. What is the ratio of the Expenses (in $) in Czech Republic in 2007 to that in 2008?
Ensure brevity in your answer.  0.83. What is the ratio of the Expenses (in $) in Iran in 2007 to that in 2008?
Provide a short and direct response. 0.97. What is the ratio of the Expenses (in $) in Norway in 2007 to that in 2008?
Offer a very short reply. 0.87. What is the ratio of the Expenses (in $) of Czech Republic in 2007 to that in 2009?
Provide a short and direct response. 0.73. What is the ratio of the Expenses (in $) in Iran in 2007 to that in 2009?
Provide a succinct answer. 1.31. What is the ratio of the Expenses (in $) of Norway in 2007 to that in 2009?
Ensure brevity in your answer.  0.79. What is the ratio of the Expenses (in $) in Belgium in 2008 to that in 2009?
Provide a succinct answer. 1.06. What is the ratio of the Expenses (in $) of Czech Republic in 2008 to that in 2009?
Your answer should be very brief. 0.88. What is the ratio of the Expenses (in $) of Iran in 2008 to that in 2009?
Your answer should be compact. 1.35. What is the ratio of the Expenses (in $) of Norway in 2008 to that in 2009?
Give a very brief answer. 0.91. What is the difference between the highest and the second highest Expenses (in $) in Belgium?
Provide a succinct answer. 5.26e+08. What is the difference between the highest and the second highest Expenses (in $) of Czech Republic?
Ensure brevity in your answer.  5.42e+09. What is the difference between the highest and the second highest Expenses (in $) of Iran?
Keep it short and to the point. 2.38e+11. What is the difference between the highest and the second highest Expenses (in $) of Norway?
Provide a short and direct response. 2.15e+09. What is the difference between the highest and the lowest Expenses (in $) of Belgium?
Ensure brevity in your answer.  1.23e+09. What is the difference between the highest and the lowest Expenses (in $) in Czech Republic?
Your answer should be compact. 2.33e+1. What is the difference between the highest and the lowest Expenses (in $) of Iran?
Offer a terse response. 5.22e+12. What is the difference between the highest and the lowest Expenses (in $) in Norway?
Offer a very short reply. 8.89e+09. 